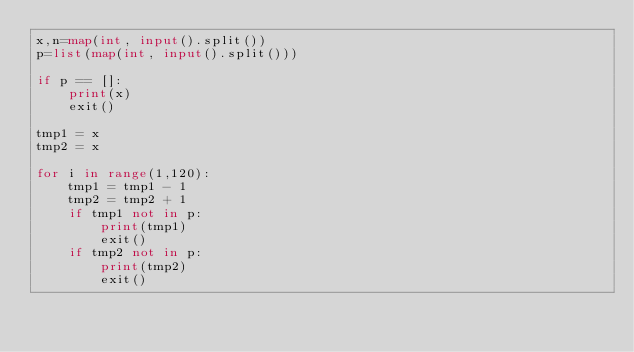<code> <loc_0><loc_0><loc_500><loc_500><_Python_>x,n=map(int, input().split())
p=list(map(int, input().split()))

if p == []:
    print(x)
    exit()

tmp1 = x
tmp2 = x

for i in range(1,120):
    tmp1 = tmp1 - 1
    tmp2 = tmp2 + 1
    if tmp1 not in p:
        print(tmp1)
        exit()
    if tmp2 not in p: 
        print(tmp2)
        exit()</code> 